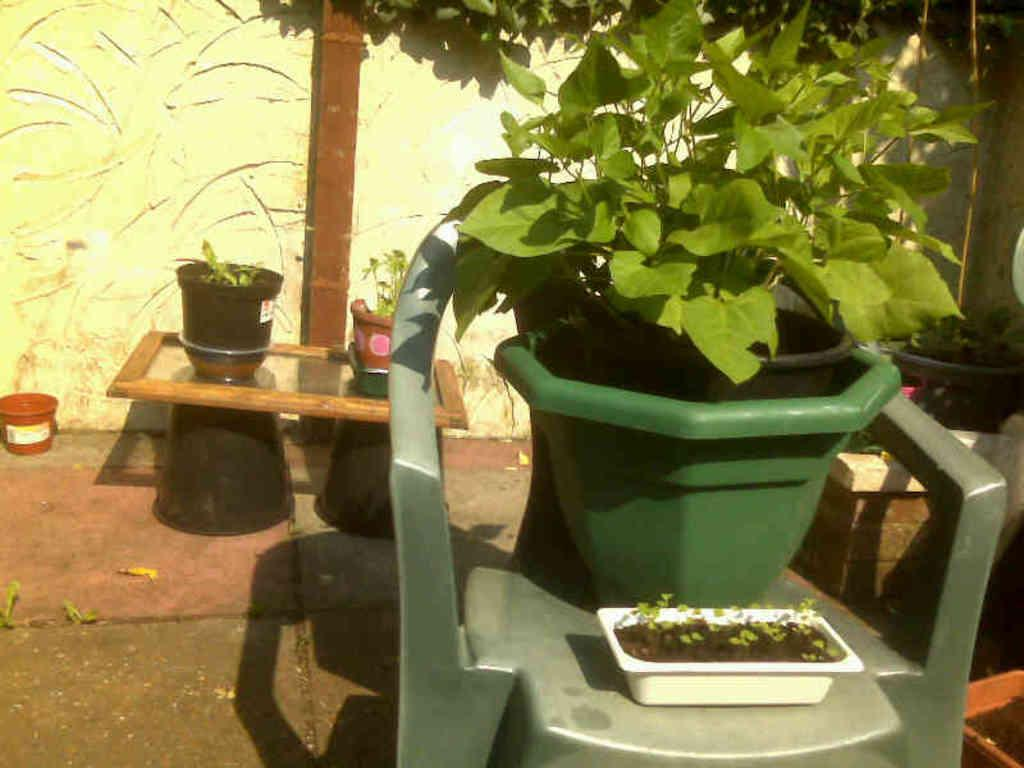What piece of furniture is present in the image? There is a chair in the image. What is placed on the chair? A flower pot is placed on the chair. What can be seen in the background of the image? There is a wall in the background of the image. What colors are used for the wall? The wall is yellow and white in color. Where was the image taken? The image was taken in a lawn area. When was the image taken? The image was taken during daytime. What word is being attempted to be spelled out by the horse in the image? There is no horse present in the image, so no such attempt can be observed. 